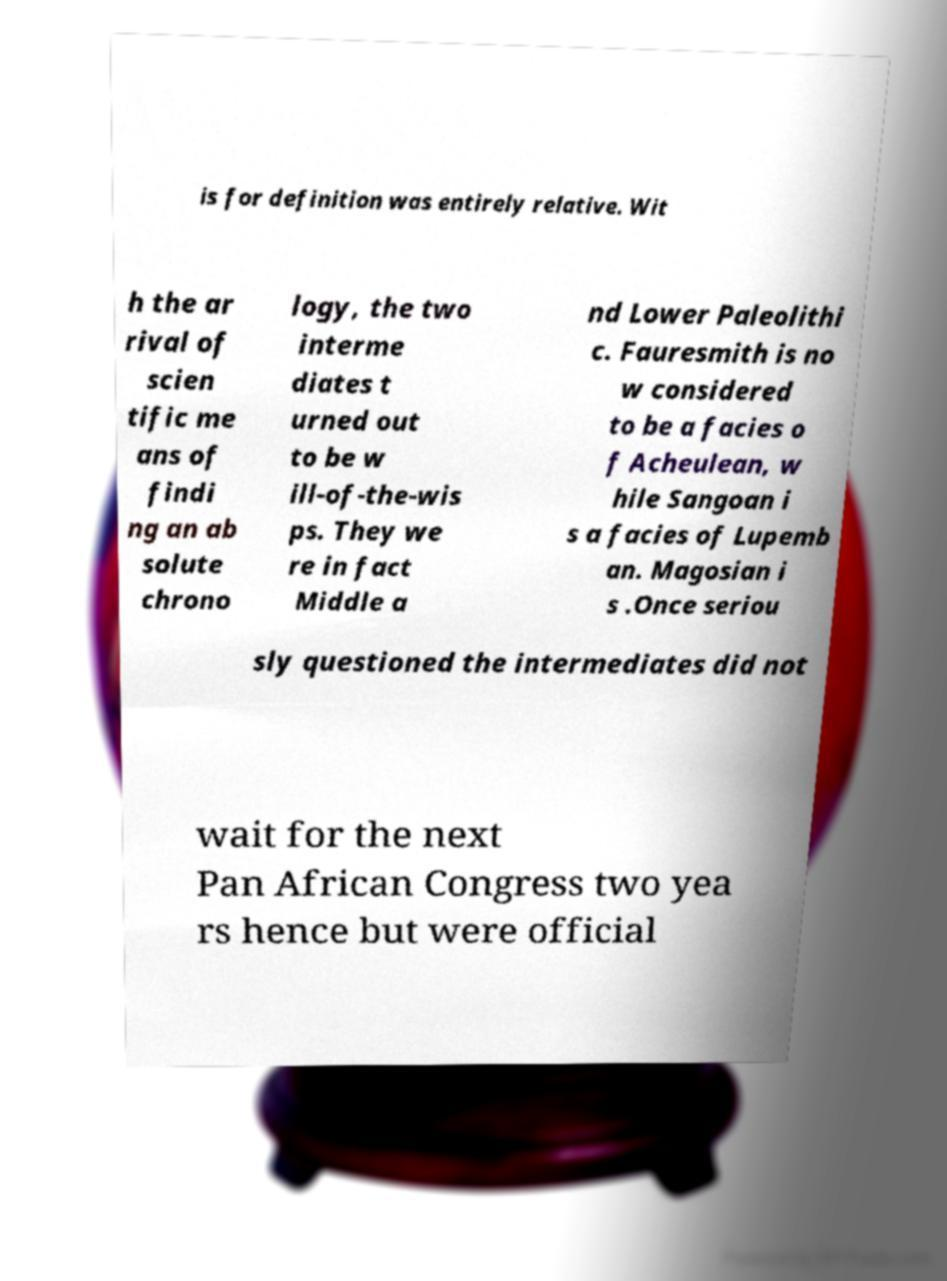Can you read and provide the text displayed in the image?This photo seems to have some interesting text. Can you extract and type it out for me? is for definition was entirely relative. Wit h the ar rival of scien tific me ans of findi ng an ab solute chrono logy, the two interme diates t urned out to be w ill-of-the-wis ps. They we re in fact Middle a nd Lower Paleolithi c. Fauresmith is no w considered to be a facies o f Acheulean, w hile Sangoan i s a facies of Lupemb an. Magosian i s .Once seriou sly questioned the intermediates did not wait for the next Pan African Congress two yea rs hence but were official 